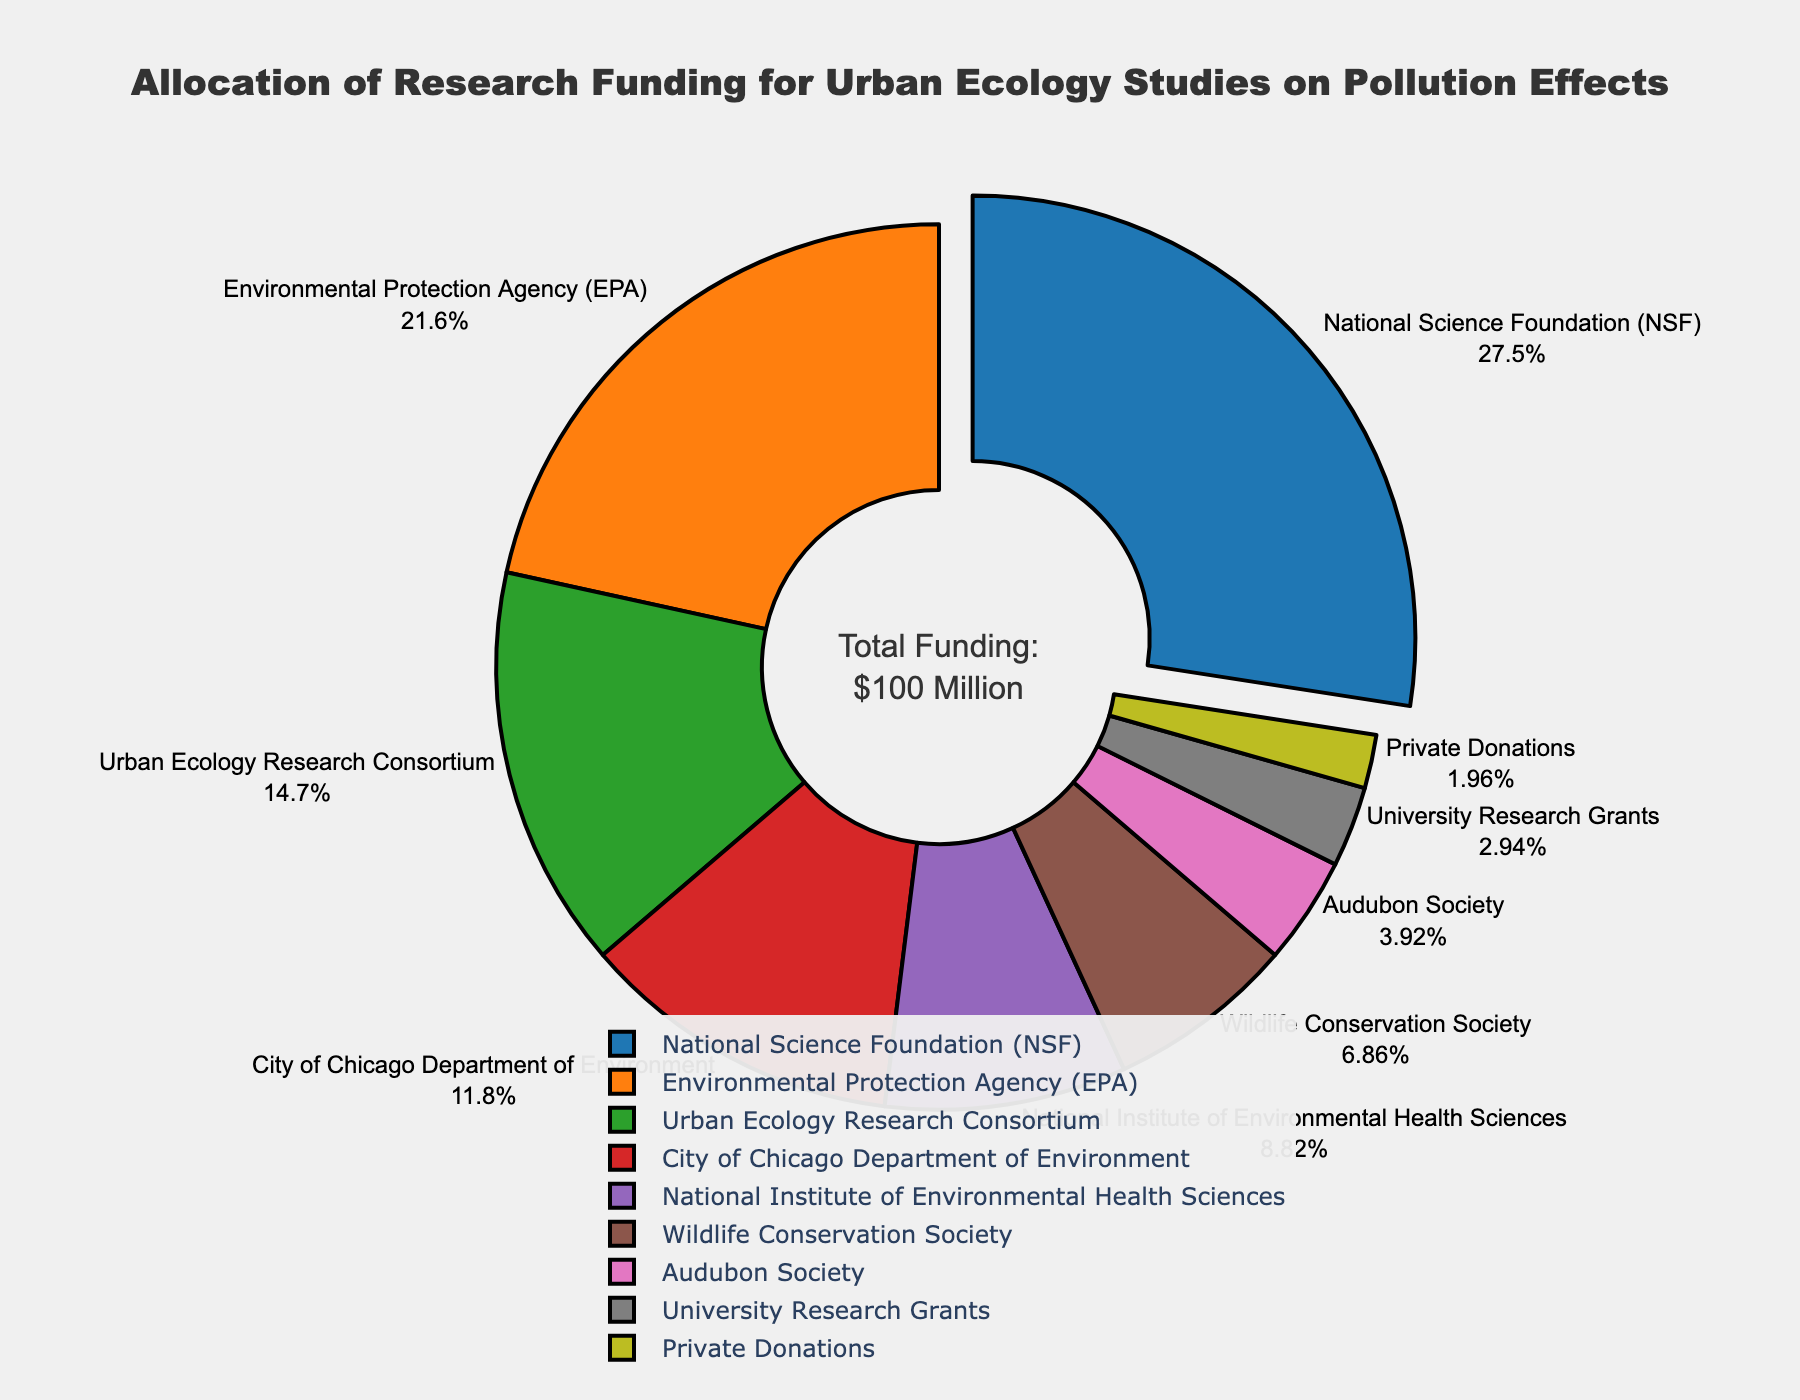Which organization receives the highest percentage of research funding? By observing the pie chart, the organization receiving the highest percentage of research funding is highlighted and 'pulled' out from the pie. This organization is the National Science Foundation (NSF) with 28% of the total funding.
Answer: National Science Foundation (NSF) What is the combined percentage of research funding from the Environmental Protection Agency (EPA) and the Urban Ecology Research Consortium? To find the combined percentage, add the percentages of funding from both organizations: EPA (22%) and Urban Ecology Research Consortium (15%). So, 22% + 15% = 37%.
Answer: 37% Which organization contributes a smaller percentage of funding, the Wildlife Conservation Society or the Audubon Society? By comparing the segments of the pie chart, we see that the Wildlife Conservation Society contributes 7%, while the Audubon Society contributes 4%. Thus, the Audubon Society contributes a smaller percentage of funding.
Answer: Audubon Society How much greater is the percentage of funding from the National Science Foundation (NSF) compared to the National Institute of Environmental Health Sciences? Subtract the percentage of the National Institute of Environmental Health Sciences (9%) from the National Science Foundation (28%). So, 28% - 9% = 19%.
Answer: 19% What is the total percentage of funding contributed by government organizations? Government organizations include the National Science Foundation (28%), Environmental Protection Agency (22%), City of Chicago Department of Environment (12%), and National Institute of Environmental Health Sciences (9%). Add these percentages: 28% + 22% + 12% + 9% = 71%.
Answer: 71% Which segment is visually marked by being 'pulled out' from the pie chart? The pie chart shows the segment for the organization with the highest funding being 'pulled out.' This segment represents the National Science Foundation (NSF) with 28% funding.
Answer: National Science Foundation (NSF) What is the difference in funding percentage between the organization with the highest funding and the organization with the least funding? The highest funding is from the National Science Foundation (28%), and the least funding is from Private Donations (2%). The difference is 28% - 2% = 26%.
Answer: 26% Which organizations have a funding contribution greater than 10%? Identify the segments with contributions greater than 10%. These organizations are the National Science Foundation (28%), Environmental Protection Agency (22%), Urban Ecology Research Consortium (15%), and City of Chicago Department of Environment (12%).
Answer: National Science Foundation, Environmental Protection Agency, Urban Ecology Research Consortium, City of Chicago Department of Environment What proportion of the total funding is allocated by non-government organizations? Non-government organizations include the Urban Ecology Research Consortium (15%), Wildlife Conservation Society (7%), Audubon Society (4%), University Research Grants (3%), and Private Donations (2%). Add these percentages: 15% + 7% + 4% + 3% + 2% = 31%.
Answer: 31% 